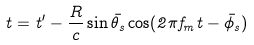<formula> <loc_0><loc_0><loc_500><loc_500>t = t ^ { \prime } - \frac { R } { c } \sin \bar { \theta } _ { s } \cos ( 2 \pi f _ { m } t - \bar { \phi } _ { s } )</formula> 